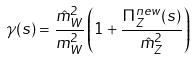<formula> <loc_0><loc_0><loc_500><loc_500>\gamma ( s ) = \frac { \hat { m } _ { W } ^ { 2 } } { m _ { W } ^ { 2 } } \left ( 1 + \frac { \Pi ^ { n e w } _ { Z } ( s ) } { \hat { m } _ { Z } ^ { 2 } } \right )</formula> 